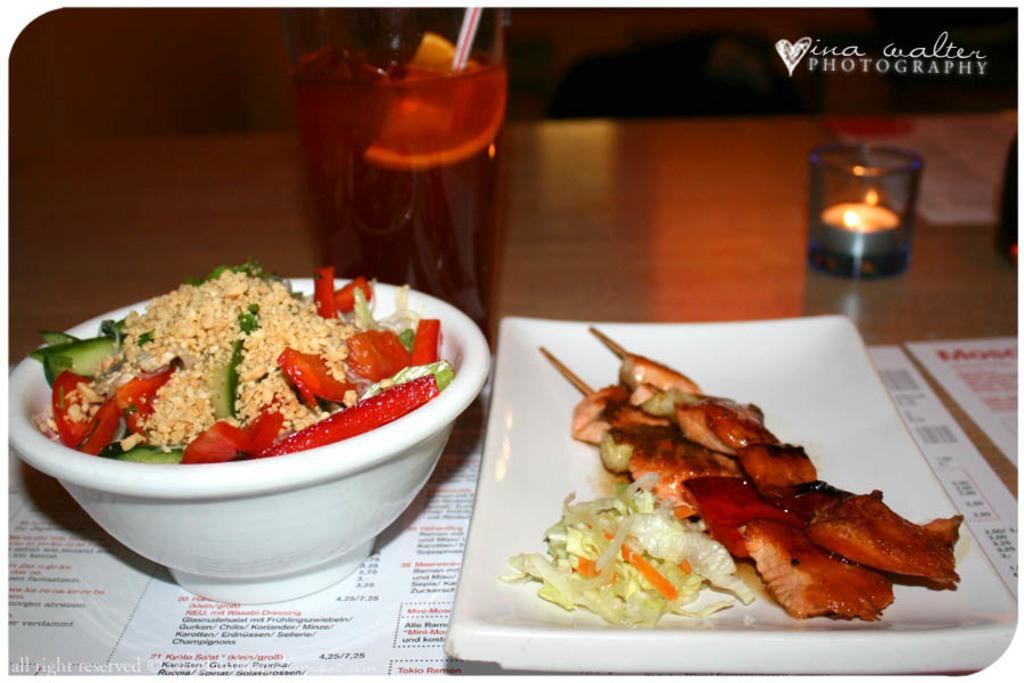In one or two sentences, can you explain what this image depicts? In this image there is a table, on that table there is a glass in that glass there is juice and a candle light, plate in that place there is food item,bowl in that bowl there is food item, in the top right there is text. 